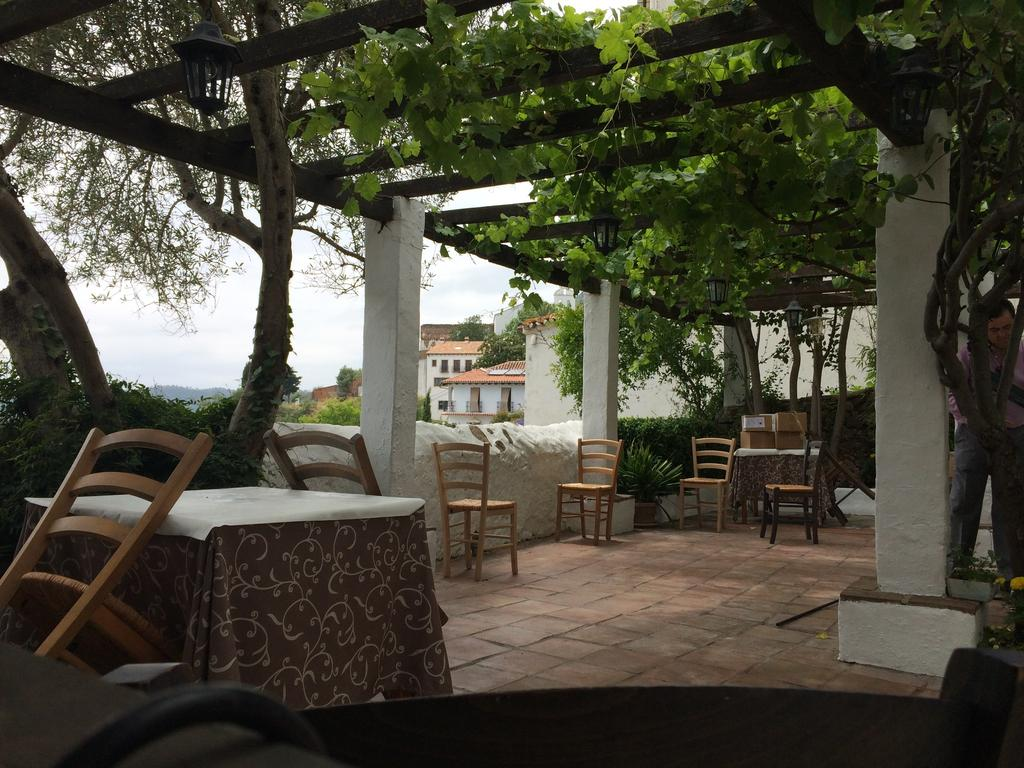What type of structures can be seen in the image? There are houses in the image. Can you describe the person in the image? There is a man standing in the image. What type of furniture is visible in the image? There are chairs and tables in the image. How would you describe the weather based on the image? The sky is cloudy in the image. What type of vegetation is present in the image? There are plants in the image. What type of glass is being used to patch the man's chin in the image? There is no glass or patch visible on the man's chin in the image. What type of chin does the man have in the image? The image does not provide enough detail to describe the man's chin. 